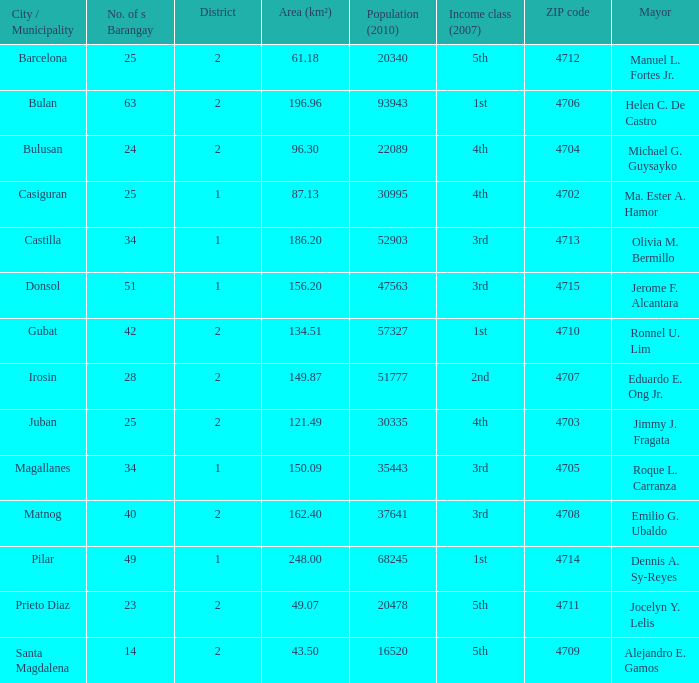Can you parse all the data within this table? {'header': ['City / Municipality', 'No. of s Barangay', 'District', 'Area (km²)', 'Population (2010)', 'Income class (2007)', 'ZIP code', 'Mayor'], 'rows': [['Barcelona', '25', '2', '61.18', '20340', '5th', '4712', 'Manuel L. Fortes Jr.'], ['Bulan', '63', '2', '196.96', '93943', '1st', '4706', 'Helen C. De Castro'], ['Bulusan', '24', '2', '96.30', '22089', '4th', '4704', 'Michael G. Guysayko'], ['Casiguran', '25', '1', '87.13', '30995', '4th', '4702', 'Ma. Ester A. Hamor'], ['Castilla', '34', '1', '186.20', '52903', '3rd', '4713', 'Olivia M. Bermillo'], ['Donsol', '51', '1', '156.20', '47563', '3rd', '4715', 'Jerome F. Alcantara'], ['Gubat', '42', '2', '134.51', '57327', '1st', '4710', 'Ronnel U. Lim'], ['Irosin', '28', '2', '149.87', '51777', '2nd', '4707', 'Eduardo E. Ong Jr.'], ['Juban', '25', '2', '121.49', '30335', '4th', '4703', 'Jimmy J. Fragata'], ['Magallanes', '34', '1', '150.09', '35443', '3rd', '4705', 'Roque L. Carranza'], ['Matnog', '40', '2', '162.40', '37641', '3rd', '4708', 'Emilio G. Ubaldo'], ['Pilar', '49', '1', '248.00', '68245', '1st', '4714', 'Dennis A. Sy-Reyes'], ['Prieto Diaz', '23', '2', '49.07', '20478', '5th', '4711', 'Jocelyn Y. Lelis'], ['Santa Magdalena', '14', '2', '43.50', '16520', '5th', '4709', 'Alejandro E. Gamos']]} What are all the profits elegance (2007) in which mayor is ma. Ester a. Hamor 4th. 